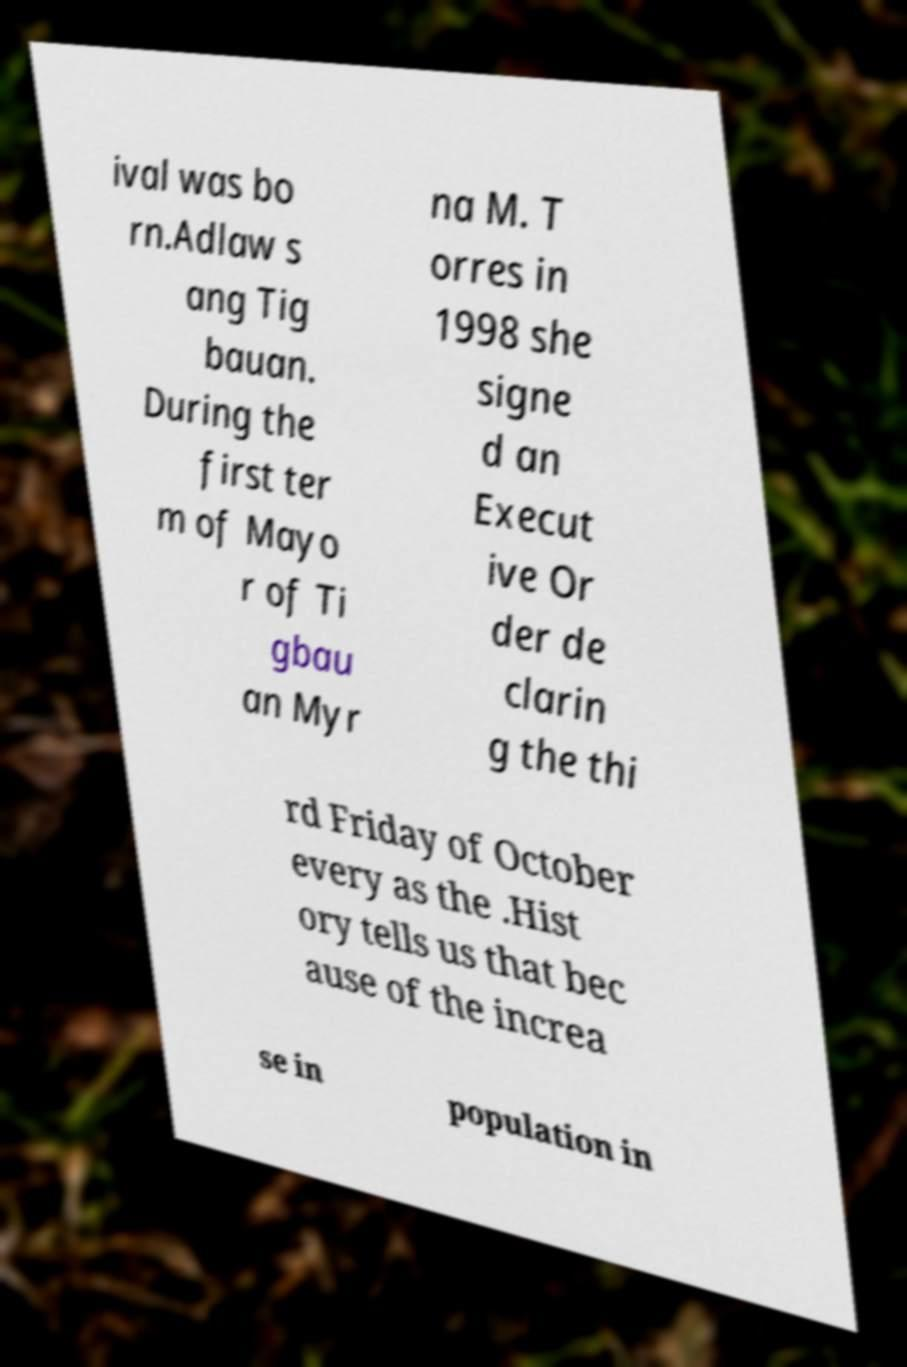I need the written content from this picture converted into text. Can you do that? ival was bo rn.Adlaw s ang Tig bauan. During the first ter m of Mayo r of Ti gbau an Myr na M. T orres in 1998 she signe d an Execut ive Or der de clarin g the thi rd Friday of October every as the .Hist ory tells us that bec ause of the increa se in population in 